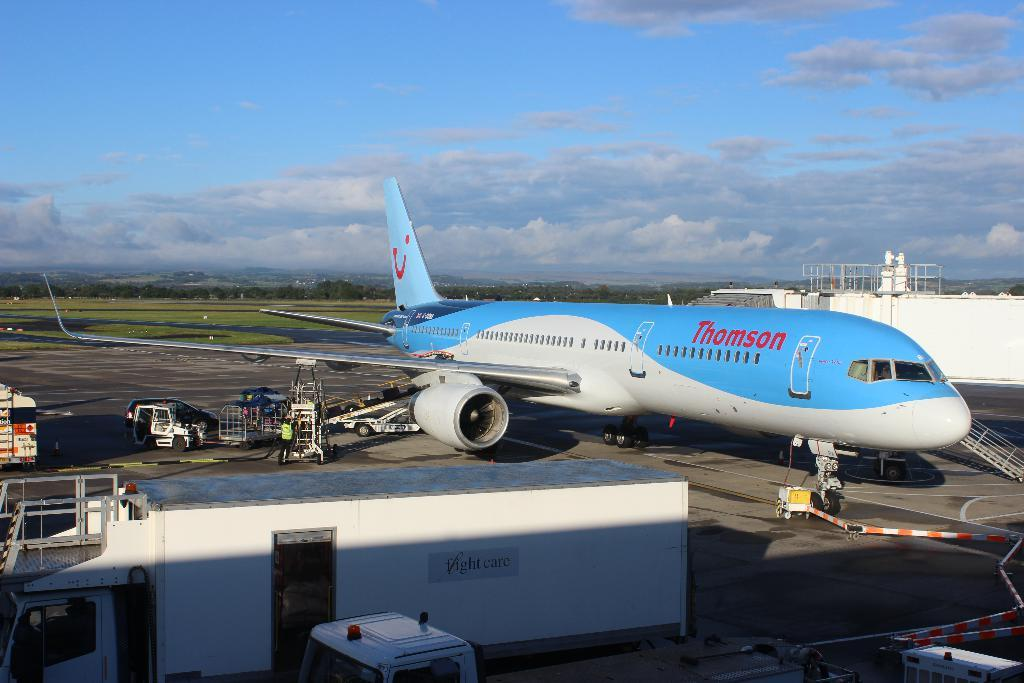Provide a one-sentence caption for the provided image. A airplane with a flowing multicolored paint job is part of the Thomson fleet. 